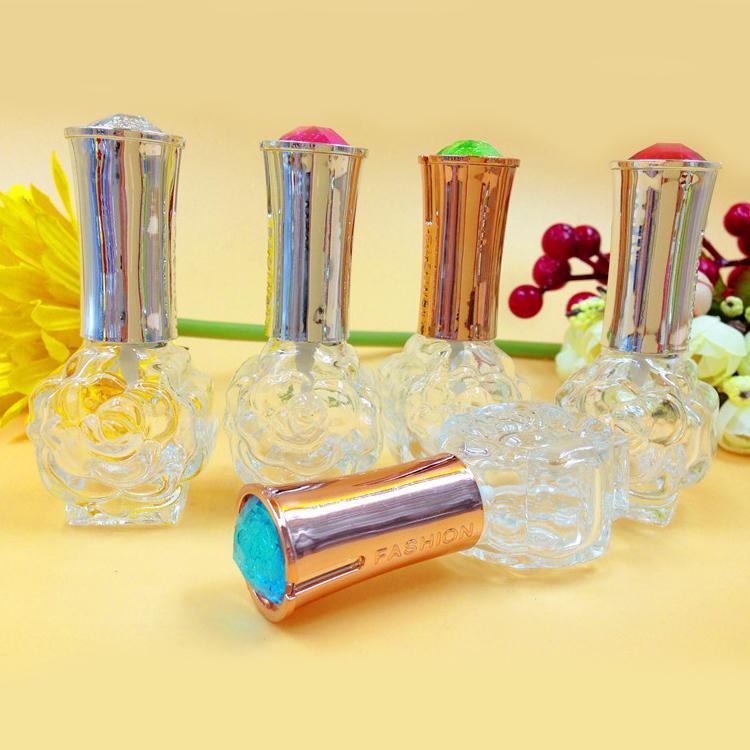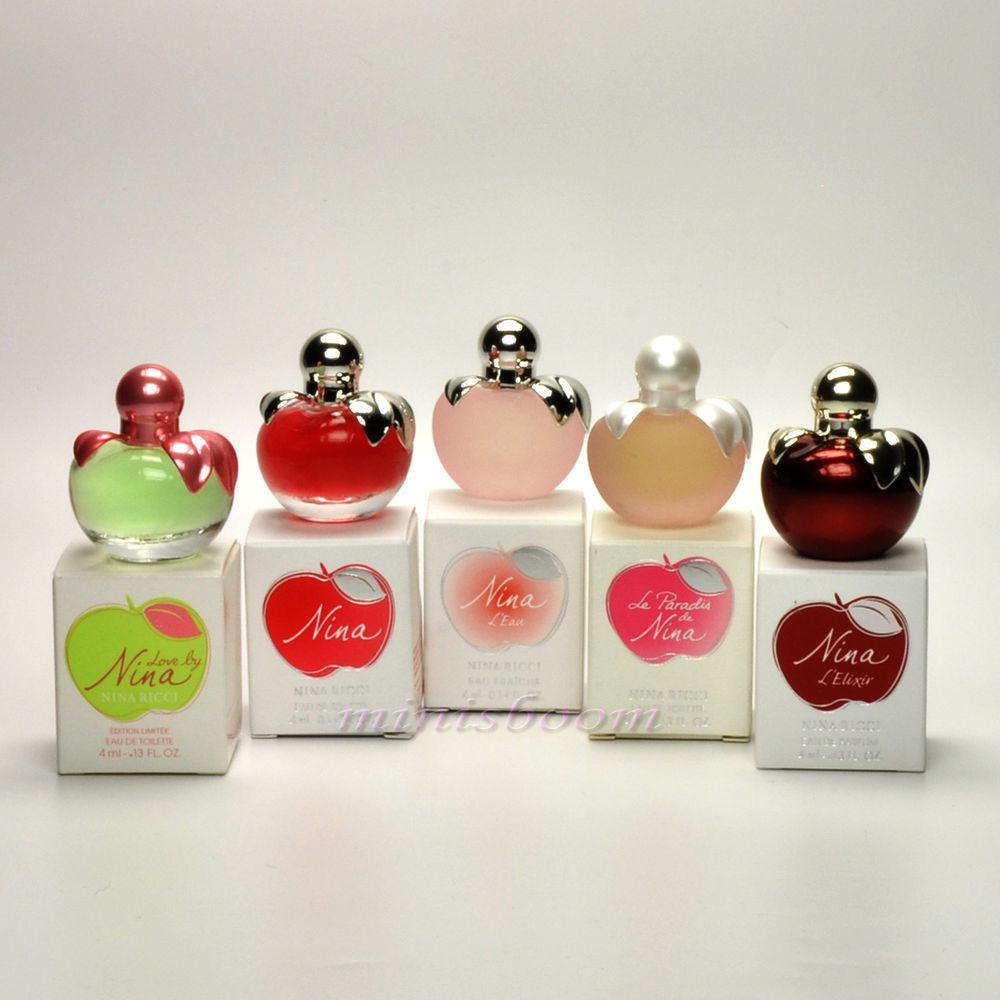The first image is the image on the left, the second image is the image on the right. Examine the images to the left and right. Is the description "One image includes a row of at least three clear glass fragrance bottles with tall metallic caps, and the other image includes several roundish bottles with round caps." accurate? Answer yes or no. Yes. The first image is the image on the left, the second image is the image on the right. Assess this claim about the two images: "All products are standing upright.". Correct or not? Answer yes or no. No. 